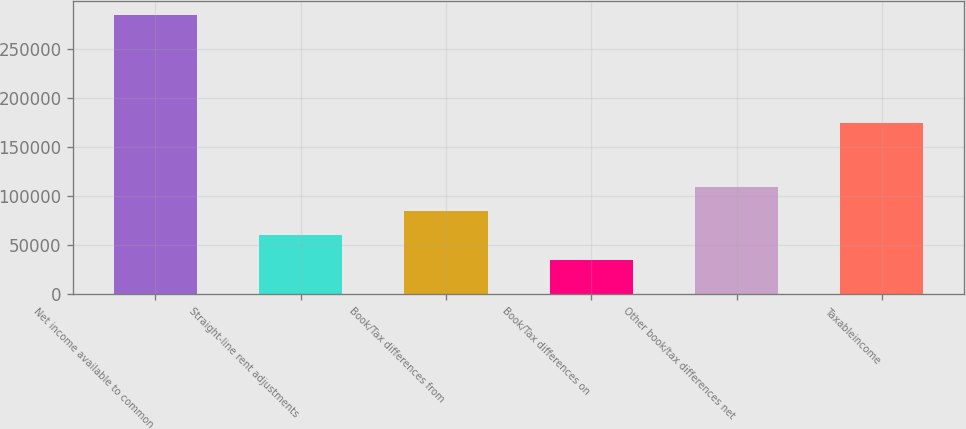<chart> <loc_0><loc_0><loc_500><loc_500><bar_chart><fcel>Net income available to common<fcel>Straight-line rent adjustments<fcel>Book/Tax differences from<fcel>Book/Tax differences on<fcel>Other book/tax differences net<fcel>Taxableincome<nl><fcel>284017<fcel>60017.8<fcel>84906.6<fcel>35129<fcel>109795<fcel>174670<nl></chart> 